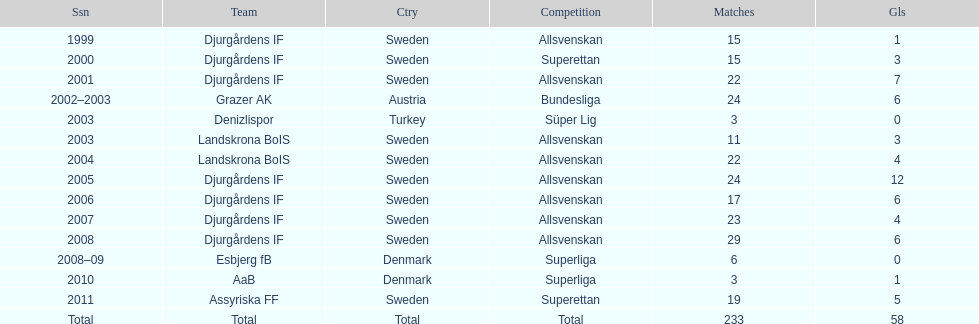How many total goals has jones kusi-asare scored? 58. 